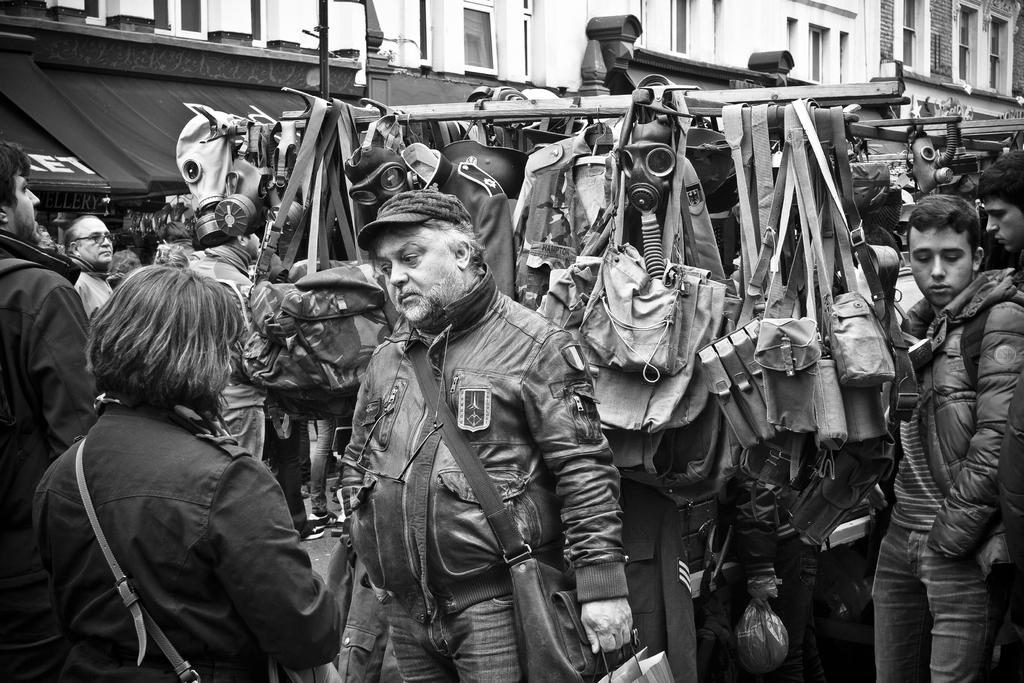What is the main subject in the middle of the image? There is a man standing in the middle of the image. What is the man wearing? The man is wearing a coat, trousers, and a cap. Who else is present in the image? There is a woman on the left side of the image. What objects can be seen in the middle of the image? There are bags in the middle of the image. How many dinosaurs are visible in the image? There are no dinosaurs present in the image. What type of tree is growing in the middle of the image? There is no tree present in the image. 